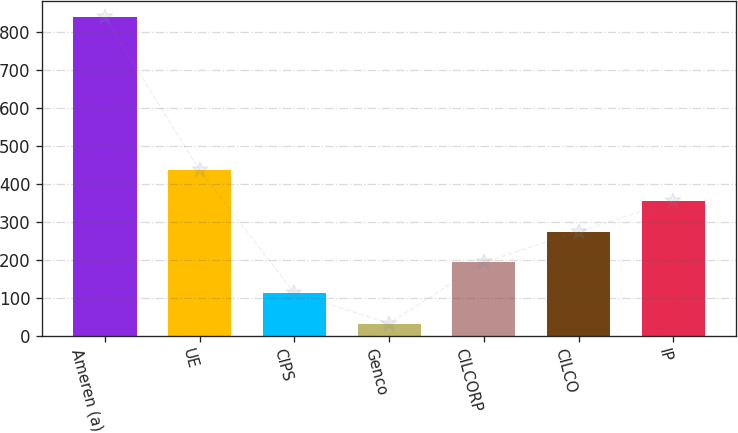Convert chart to OTSL. <chart><loc_0><loc_0><loc_500><loc_500><bar_chart><fcel>Ameren (a)<fcel>UE<fcel>CIPS<fcel>Genco<fcel>CILCORP<fcel>CILCO<fcel>IP<nl><fcel>839<fcel>435.5<fcel>112.7<fcel>32<fcel>193.4<fcel>274.1<fcel>354.8<nl></chart> 